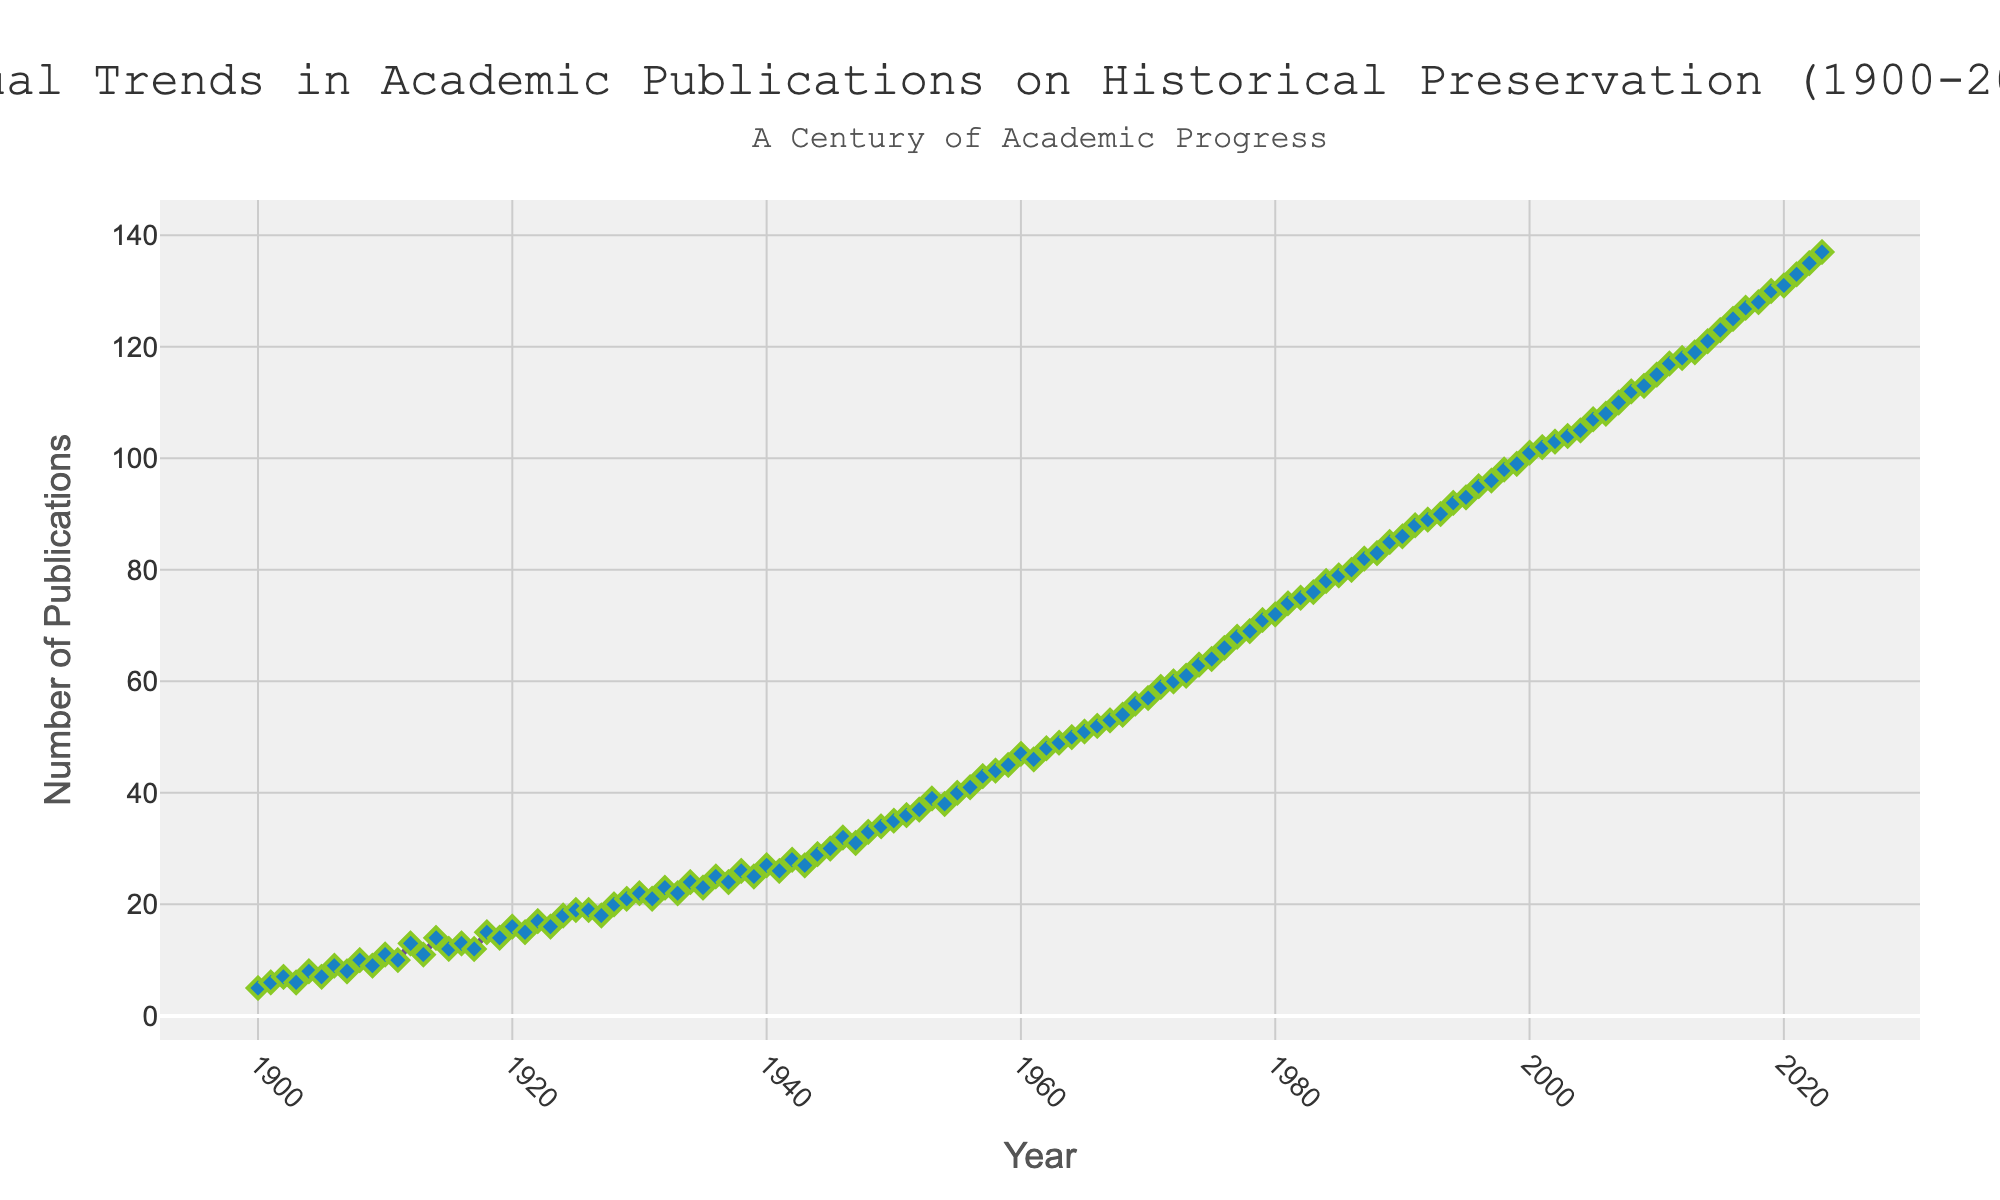what is the title of the plot? The title is displayed at the top center of the figure. It reads 'Annual Trends in Academic Publications on Historical Preservation (1900-2023)'.
Answer: 'Annual Trends in Academic Publications on Historical Preservation (1900-2023)' what does the x-axis represent? The x-axis represents the years, ranging from 1900 to 2023 with ticks every 20 years.
Answer: Years what does the y-axis represent? The y-axis represents the number of publications, with ticks every 20 publications.
Answer: Number of Publications how many publications were made in the year 1925? Find the data point for the year 1925 on the x-axis and read the corresponding y-axis value.
Answer: 19 what is the trend of publications from 1940 to 1945? Look at the data points from 1940 to 1945 and observe the pattern. The publications increased from 27 in 1940 to 30 in 1945.
Answer: Increasing compare the number of publications in 1960 and 1970. which year had more publications? Locate 1960 and 1970 on the x-axis and compare their corresponding y-axis values. 1960 had 47 publications, and 1970 had 57 publications.
Answer: 1970 what is the average number of publications in the first decade (1900-1910)? Identify the data points from 1900 to 1910, sum them, and divide by 11. The numbers are: 5, 6, 7, 6, 8, 7, 9, 8, 10, 9, 11. Sum = 86, Average = 86/11.
Answer: 7.82 how did the number of publications change from 1980 to 1985? Observe the data points from 1980 to 1985. The number of publications increased from 72 in 1980 to 79 in 1985.
Answer: Increased which year shows a rapid increase in publications compared to the previous year between 1940 and 1950? Look at the data points between 1940 and 1950 and find the year with a significant jump. The jump is from 1944 (29) to 1945 (30).
Answer: 1945 what is the annotations text added to the plot? The annotation is above the plot area in the figure, and it reads 'A Century of Academic Progress'.
Answer: 'A Century of Academic Progress' 